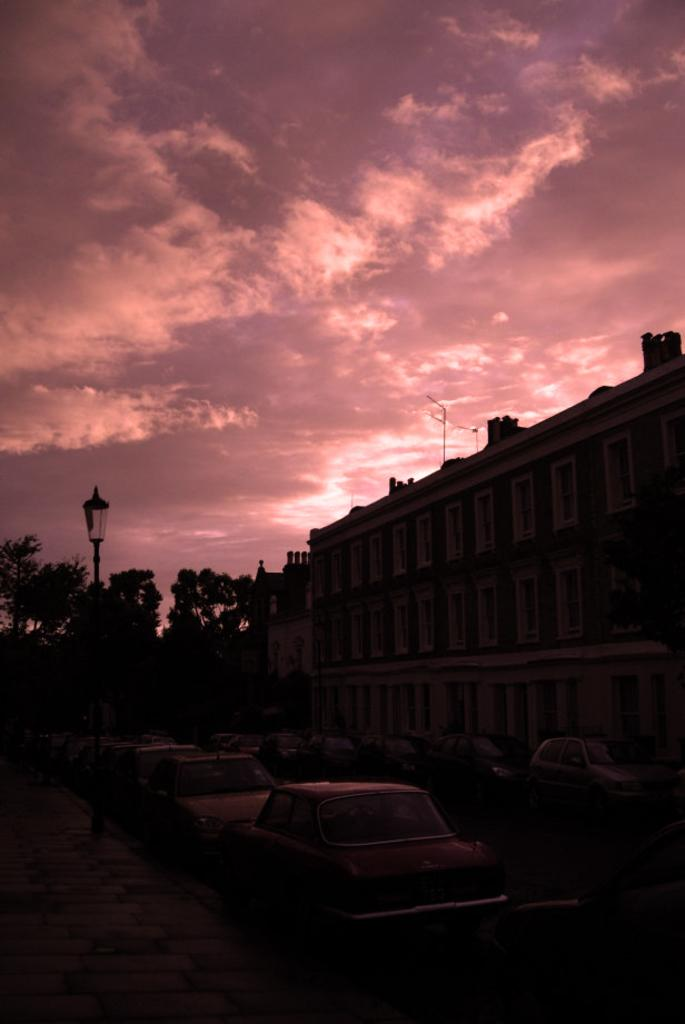What type of structures are visible in the image? There are buildings in the image. What else can be seen near the buildings? There are vehicles parked in front of the buildings. What is the purpose of the object on the side of the road? A street light is present in the image. What type of vegetation is visible in the image? There are trees in the image. What is visible in the background of the image? The sky is visible in the background of the image. What type of food can be seen growing on the trees in the image? There is no food growing on the trees in the image; they are regular trees. What type of magic is being performed by the street light in the image? There is no magic being performed by the street light in the image; it is a regular street light. 